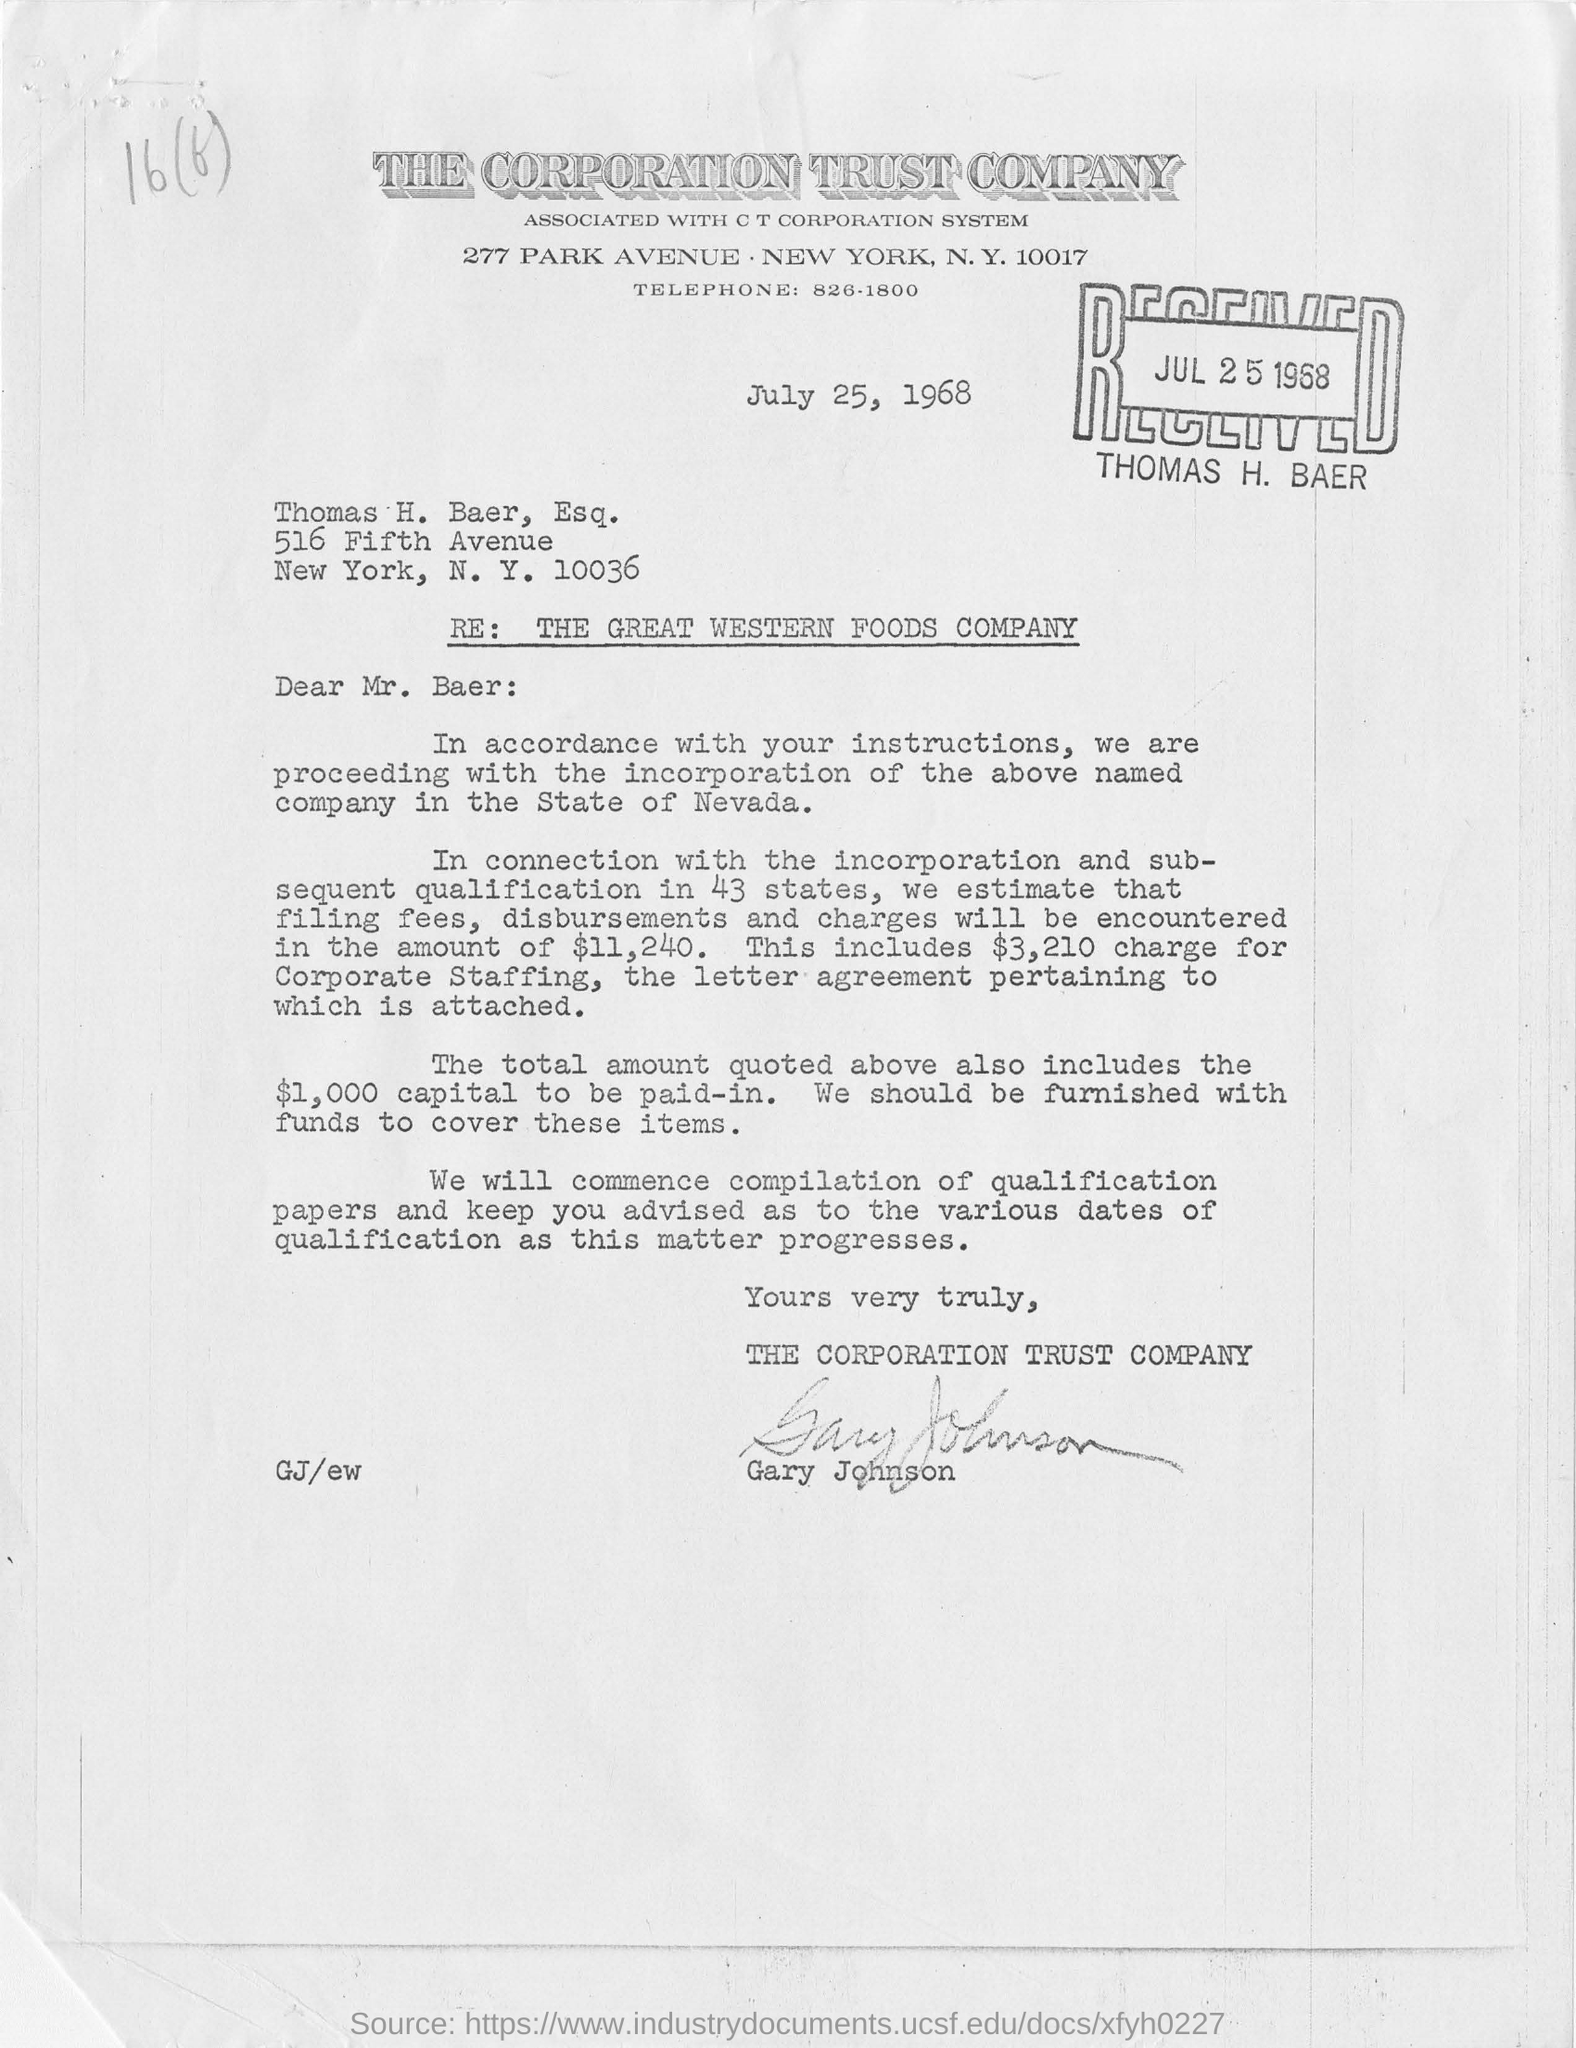What is the date mentioned in the document?
Keep it short and to the point. July 25, 1968. What is the zip code mentiioned at the top  in the letterhead??
Provide a short and direct response. 10017. When did Thomas Baer receive this letter?
Your answer should be compact. JUL 25 1968. Whose name is on the stamp?
Provide a succinct answer. Thomas H. Baer. 